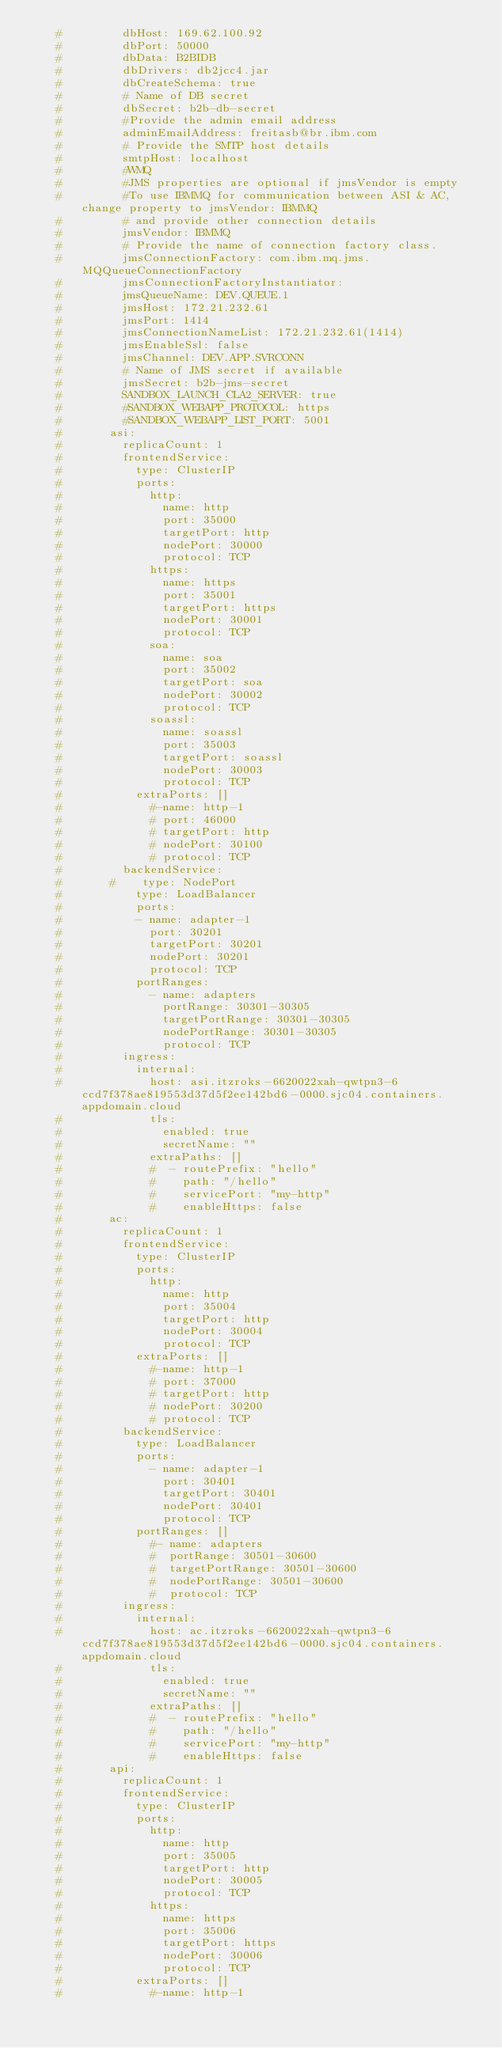Convert code to text. <code><loc_0><loc_0><loc_500><loc_500><_YAML_>    #         dbHost: 169.62.100.92
    #         dbPort: 50000
    #         dbData: B2BIDB
    #         dbDrivers: db2jcc4.jar
    #         dbCreateSchema: true
    #         # Name of DB secret
    #         dbSecret: b2b-db-secret
    #         #Provide the admin email address
    #         adminEmailAddress: freitasb@br.ibm.com
    #         # Provide the SMTP host details
    #         smtpHost: localhost
    #         #WMQ
    #         #JMS properties are optional if jmsVendor is empty
    #         #To use IBMMQ for communication between ASI & AC, change property to jmsVendor: IBMMQ
    #         # and provide other connection details
    #         jmsVendor: IBMMQ
    #         # Provide the name of connection factory class.
    #         jmsConnectionFactory: com.ibm.mq.jms.MQQueueConnectionFactory
    #         jmsConnectionFactoryInstantiator:
    #         jmsQueueName: DEV.QUEUE.1
    #         jmsHost: 172.21.232.61
    #         jmsPort: 1414
    #         jmsConnectionNameList: 172.21.232.61(1414)
    #         jmsEnableSsl: false
    #         jmsChannel: DEV.APP.SVRCONN
    #         # Name of JMS secret if available
    #         jmsSecret: b2b-jms-secret
    #         SANDBOX_LAUNCH_CLA2_SERVER: true
    #         #SANDBOX_WEBAPP_PROTOCOL: https
    #         #SANDBOX_WEBAPP_LIST_PORT: 5001
    #       asi:
    #         replicaCount: 1
    #         frontendService:
    #           type: ClusterIP
    #           ports:
    #             http:
    #               name: http
    #               port: 35000
    #               targetPort: http
    #               nodePort: 30000
    #               protocol: TCP
    #             https:
    #               name: https
    #               port: 35001
    #               targetPort: https
    #               nodePort: 30001
    #               protocol: TCP
    #             soa:
    #               name: soa
    #               port: 35002
    #               targetPort: soa
    #               nodePort: 30002
    #               protocol: TCP
    #             soassl:
    #               name: soassl
    #               port: 35003
    #               targetPort: soassl
    #               nodePort: 30003
    #               protocol: TCP
    #           extraPorts: []
    #             #-name: http-1
    #             # port: 46000
    #             # targetPort: http
    #             # nodePort: 30100
    #             # protocol: TCP
    #         backendService:
    #       #    type: NodePort
    #           type: LoadBalancer
    #           ports:
    #           - name: adapter-1
    #             port: 30201
    #             targetPort: 30201
    #             nodePort: 30201
    #             protocol: TCP
    #           portRanges:
    #             - name: adapters
    #               portRange: 30301-30305
    #               targetPortRange: 30301-30305
    #               nodePortRange: 30301-30305
    #               protocol: TCP
    #         ingress:
    #           internal:
    #             host: asi.itzroks-6620022xah-qwtpn3-6ccd7f378ae819553d37d5f2ee142bd6-0000.sjc04.containers.appdomain.cloud
    #             tls:
    #               enabled: true
    #               secretName: ""
    #             extraPaths: []
    #             #  - routePrefix: "hello"
    #             #    path: "/hello"
    #             #    servicePort: "my-http"
    #             #    enableHttps: false
    #       ac:
    #         replicaCount: 1
    #         frontendService:
    #           type: ClusterIP
    #           ports:
    #             http:
    #               name: http
    #               port: 35004
    #               targetPort: http
    #               nodePort: 30004
    #               protocol: TCP
    #           extraPorts: []
    #             #-name: http-1
    #             # port: 37000
    #             # targetPort: http
    #             # nodePort: 30200
    #             # protocol: TCP
    #         backendService:
    #           type: LoadBalancer
    #           ports:
    #             - name: adapter-1
    #               port: 30401
    #               targetPort: 30401
    #               nodePort: 30401
    #               protocol: TCP
    #           portRanges: []
    #             #- name: adapters
    #             #  portRange: 30501-30600
    #             #  targetPortRange: 30501-30600
    #             #  nodePortRange: 30501-30600
    #             #  protocol: TCP
    #         ingress:
    #           internal:
    #             host: ac.itzroks-6620022xah-qwtpn3-6ccd7f378ae819553d37d5f2ee142bd6-0000.sjc04.containers.appdomain.cloud
    #             tls:
    #               enabled: true
    #               secretName: ""
    #             extraPaths: []
    #             #  - routePrefix: "hello"
    #             #    path: "/hello"
    #             #    servicePort: "my-http"
    #             #    enableHttps: false
    #       api:
    #         replicaCount: 1
    #         frontendService:
    #           type: ClusterIP
    #           ports:
    #             http:
    #               name: http
    #               port: 35005
    #               targetPort: http
    #               nodePort: 30005
    #               protocol: TCP
    #             https:
    #               name: https
    #               port: 35006
    #               targetPort: https
    #               nodePort: 30006
    #               protocol: TCP
    #           extraPorts: []
    #             #-name: http-1</code> 